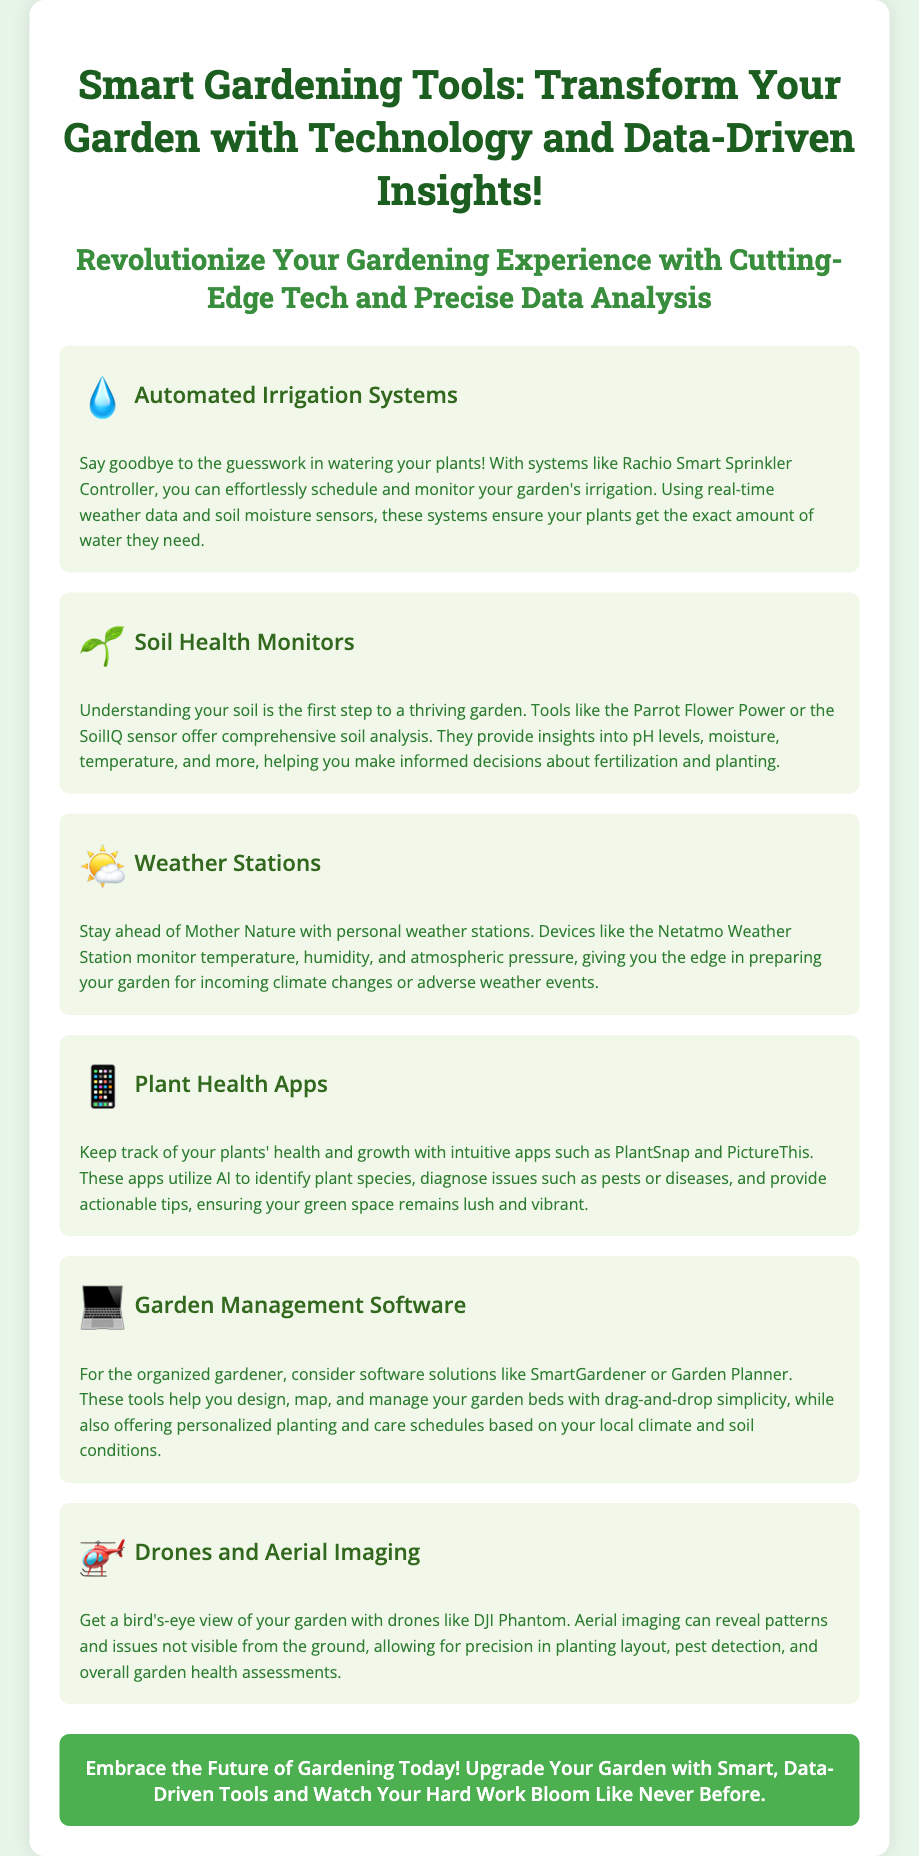What is the title of the advertisement? The title is found at the very beginning of the document, which is "Smart Gardening Tools: Transform Your Garden with Technology and Data-Driven Insights!"
Answer: Smart Gardening Tools: Transform Your Garden with Technology and Data-Driven Insights! What tool helps automate watering based on real-time data? The document mentions the Rachio Smart Sprinkler Controller as an example of an automated irrigation system that uses real-time weather data and soil moisture sensors.
Answer: Rachio Smart Sprinkler Controller Which plant health app is mentioned in the advertisement? The advertisement lists PlantSnap and PictureThis as examples of plant health apps.
Answer: PlantSnap What is the purpose of soil health monitors? The soil health monitors provide insights into soil conditions, helping gardeners make informed decisions about fertilization and planting.
Answer: Comprehensive soil analysis How do weather stations benefit gardeners? Weather stations monitor various environmental factors such as temperature and humidity, which helps gardeners prepare for climate changes.
Answer: Prepare for climate changes What type of drones does the advertisement refer to? The document mentions drones like DJI Phantom, specifically used for aerial imaging of gardens.
Answer: DJI Phantom 